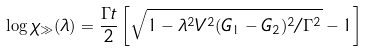<formula> <loc_0><loc_0><loc_500><loc_500>\log \chi _ { \gg } ( \lambda ) = \frac { \Gamma t } { 2 } \left [ \sqrt { 1 - \lambda ^ { 2 } V ^ { 2 } ( G _ { 1 } - G _ { 2 } ) ^ { 2 } / \Gamma ^ { 2 } } - 1 \right ]</formula> 